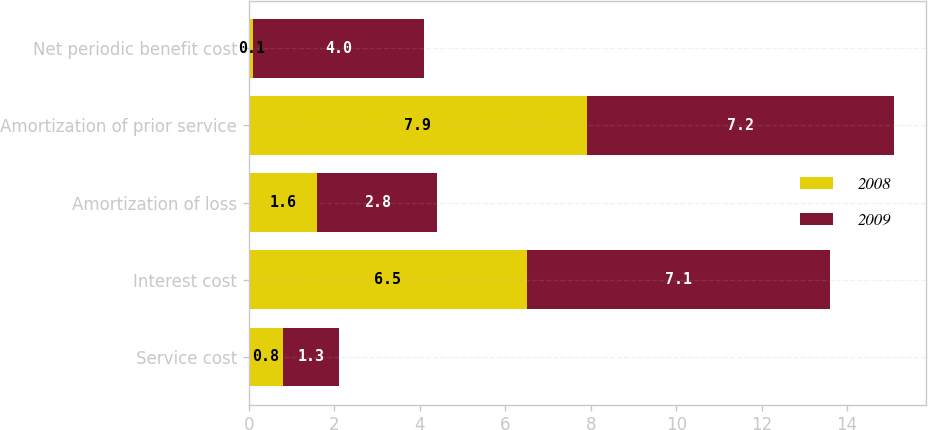Convert chart to OTSL. <chart><loc_0><loc_0><loc_500><loc_500><stacked_bar_chart><ecel><fcel>Service cost<fcel>Interest cost<fcel>Amortization of loss<fcel>Amortization of prior service<fcel>Net periodic benefit cost<nl><fcel>2008<fcel>0.8<fcel>6.5<fcel>1.6<fcel>7.9<fcel>0.1<nl><fcel>2009<fcel>1.3<fcel>7.1<fcel>2.8<fcel>7.2<fcel>4<nl></chart> 